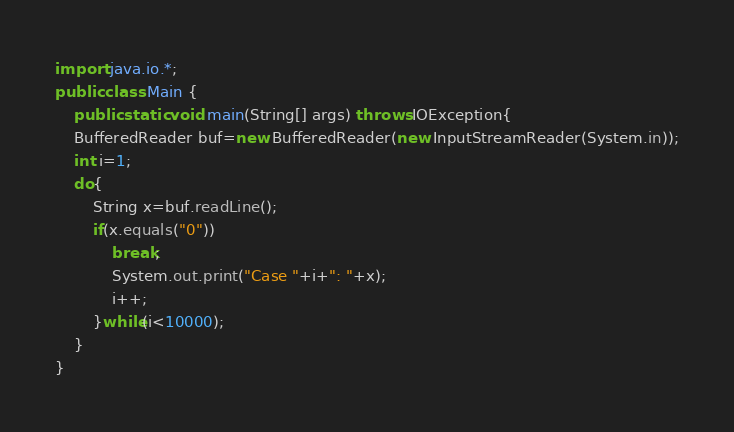<code> <loc_0><loc_0><loc_500><loc_500><_Java_>import java.io.*;
public class Main {
    public static void main(String[] args) throws IOException{
    BufferedReader buf=new BufferedReader(new InputStreamReader(System.in));
    int i=1;
    do{
        String x=buf.readLine();
        if(x.equals("0"))
            break;
            System.out.print("Case "+i+": "+x);
            i++;
        }while(i<10000);
    }
}</code> 